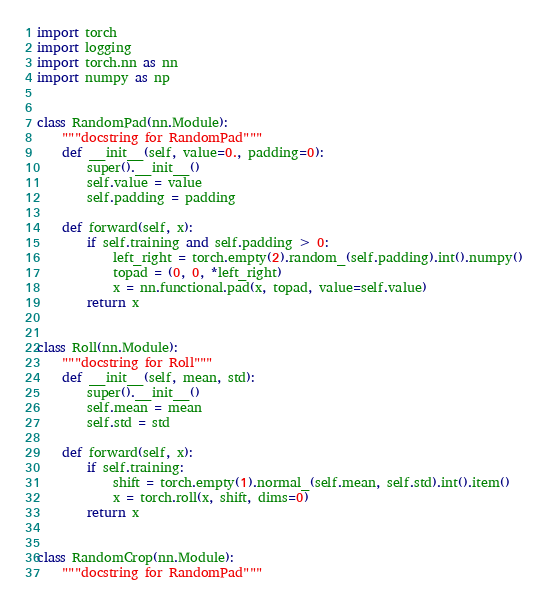<code> <loc_0><loc_0><loc_500><loc_500><_Python_>import torch
import logging
import torch.nn as nn
import numpy as np


class RandomPad(nn.Module):
    """docstring for RandomPad"""
    def __init__(self, value=0., padding=0):
        super().__init__()
        self.value = value
        self.padding = padding

    def forward(self, x):
        if self.training and self.padding > 0:
            left_right = torch.empty(2).random_(self.padding).int().numpy()
            topad = (0, 0, *left_right)
            x = nn.functional.pad(x, topad, value=self.value)
        return x


class Roll(nn.Module):
    """docstring for Roll"""
    def __init__(self, mean, std):
        super().__init__()
        self.mean = mean
        self.std = std

    def forward(self, x):
        if self.training:
            shift = torch.empty(1).normal_(self.mean, self.std).int().item()
            x = torch.roll(x, shift, dims=0)
        return x


class RandomCrop(nn.Module):
    """docstring for RandomPad"""</code> 